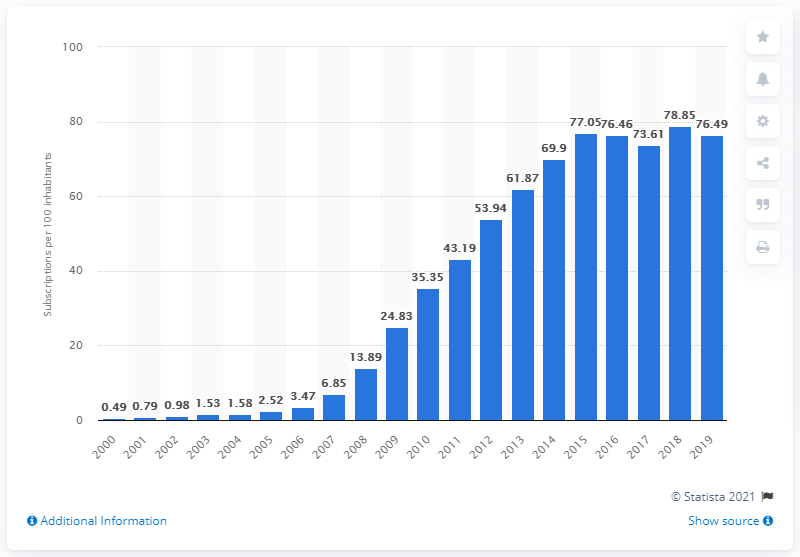Give some essential details in this illustration. In Rwanda, between 2000 and 2019, there were an average of 76.49 mobile subscriptions for every 100 people. There were approximately 20 mobile cellular subscriptions per 100 inhabitants in Rwanda in the year 2000. 